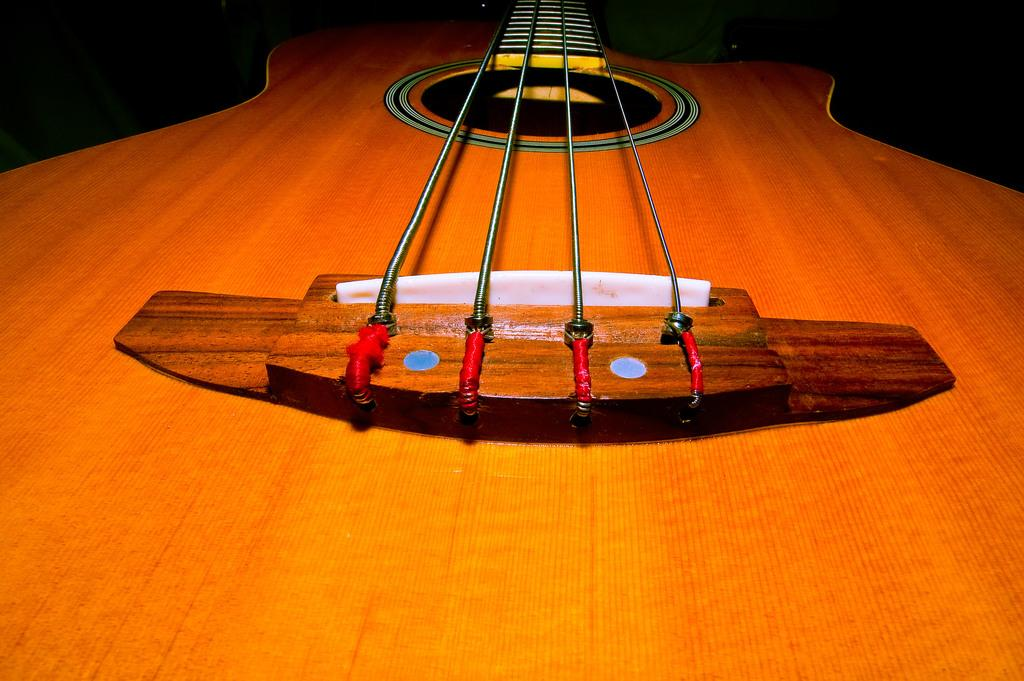What musical instrument is present in the picture? There is a guitar in the picture. How many strings does the guitar have? The guitar has four strings. What feature is present on the guitar for producing sound? The guitar has a music hole. What is the color of the guitar? The guitar is brown in color. What type of vegetable is growing out of the guitar's nose in the image? There is no vegetable growing out of the guitar's nose in the image, as guitars do not have noses. 